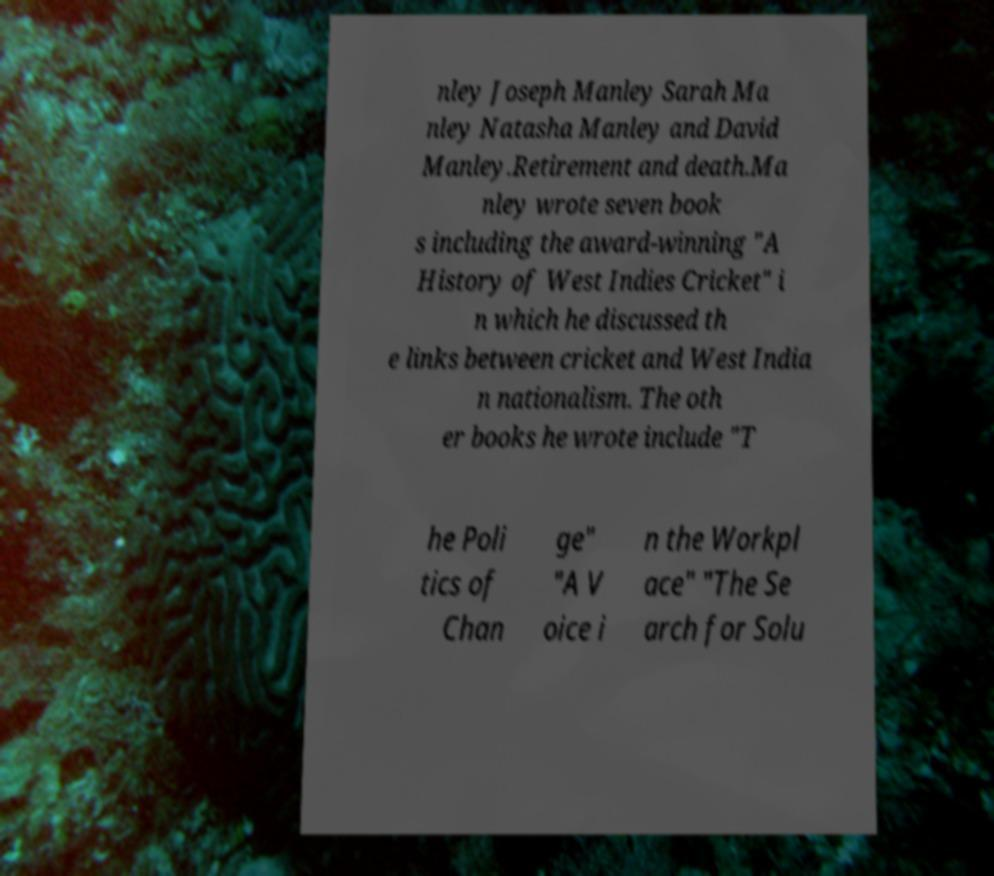Please identify and transcribe the text found in this image. nley Joseph Manley Sarah Ma nley Natasha Manley and David Manley.Retirement and death.Ma nley wrote seven book s including the award-winning "A History of West Indies Cricket" i n which he discussed th e links between cricket and West India n nationalism. The oth er books he wrote include "T he Poli tics of Chan ge" "A V oice i n the Workpl ace" "The Se arch for Solu 